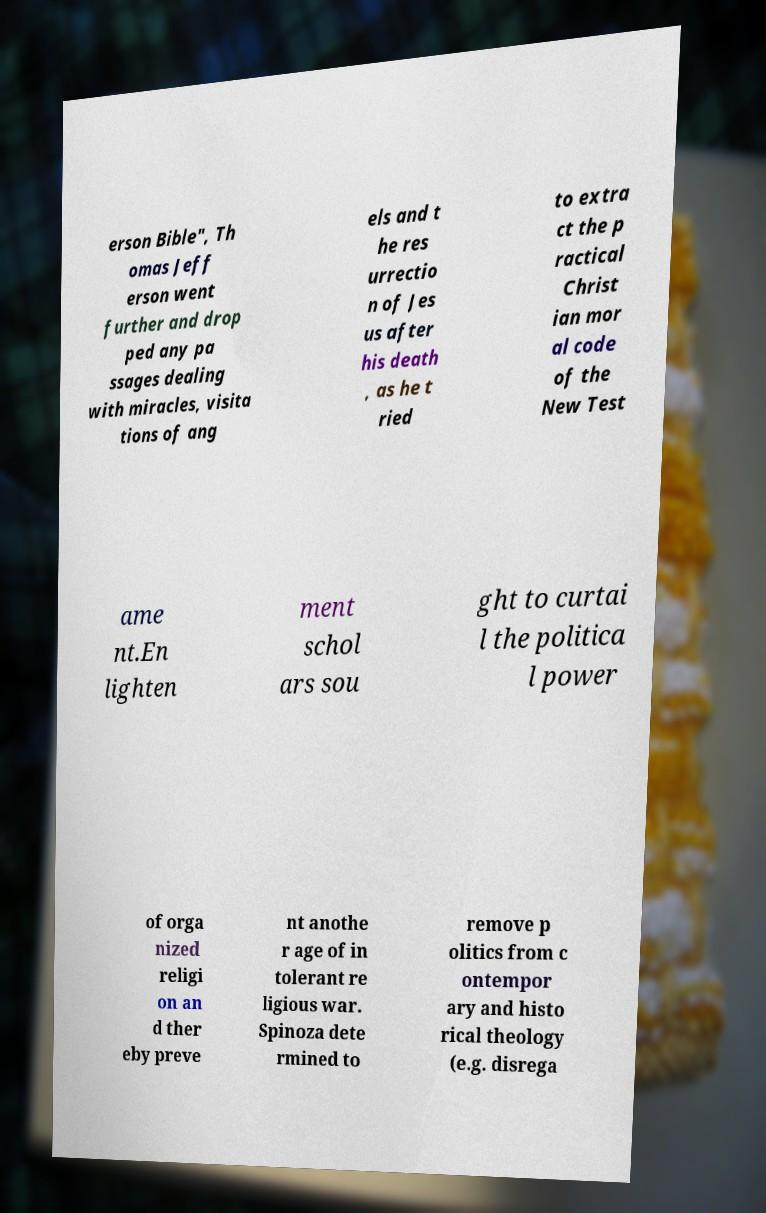Could you assist in decoding the text presented in this image and type it out clearly? erson Bible", Th omas Jeff erson went further and drop ped any pa ssages dealing with miracles, visita tions of ang els and t he res urrectio n of Jes us after his death , as he t ried to extra ct the p ractical Christ ian mor al code of the New Test ame nt.En lighten ment schol ars sou ght to curtai l the politica l power of orga nized religi on an d ther eby preve nt anothe r age of in tolerant re ligious war. Spinoza dete rmined to remove p olitics from c ontempor ary and histo rical theology (e.g. disrega 